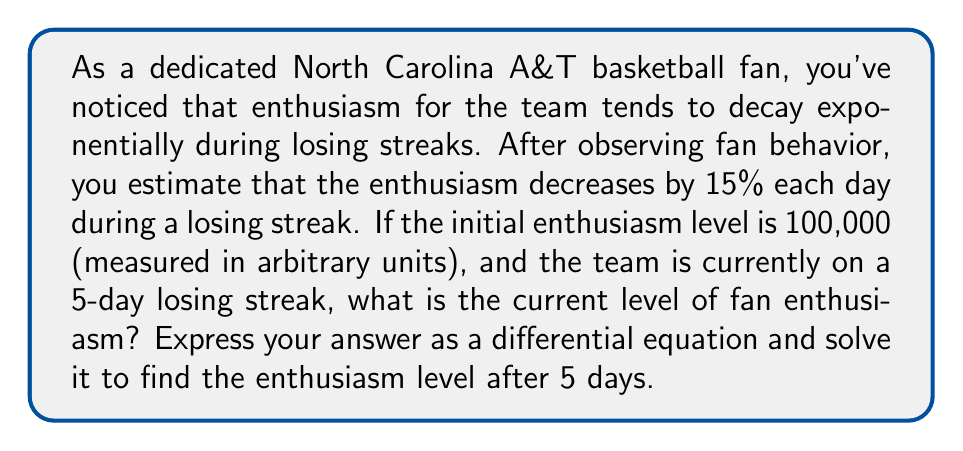Could you help me with this problem? Let's approach this problem step by step:

1) First, we need to set up our differential equation. Let $E(t)$ be the enthusiasm level at time $t$ (measured in days).

2) The rate of change of enthusiasm is proportional to the current enthusiasm level. This can be expressed as:

   $$\frac{dE}{dt} = -kE$$

   where $k$ is the decay constant.

3) We're told that the enthusiasm decreases by 15% each day. This means that after one day, the remaining enthusiasm is 85% of the original. We can use this to find $k$:

   $$e^{-k} = 0.85$$
   $$k = -\ln(0.85) \approx 0.1625$$

4) Now our differential equation is:

   $$\frac{dE}{dt} = -0.1625E$$

5) The general solution to this differential equation is:

   $$E(t) = Ce^{-0.1625t}$$

   where $C$ is a constant we need to determine from the initial conditions.

6) We're told that the initial enthusiasm is 100,000, so:

   $$E(0) = 100000 = Ce^{-0.1625(0)} = C$$

7) Therefore, our specific solution is:

   $$E(t) = 100000e^{-0.1625t}$$

8) To find the enthusiasm after 5 days, we calculate $E(5)$:

   $$E(5) = 100000e^{-0.1625(5)} \approx 44,517$$
Answer: The differential equation describing the decay of enthusiasm is:

$$\frac{dE}{dt} = -0.1625E$$

with the solution:

$$E(t) = 100000e^{-0.1625t}$$

After 5 days, the enthusiasm level is approximately 44,517 units. 